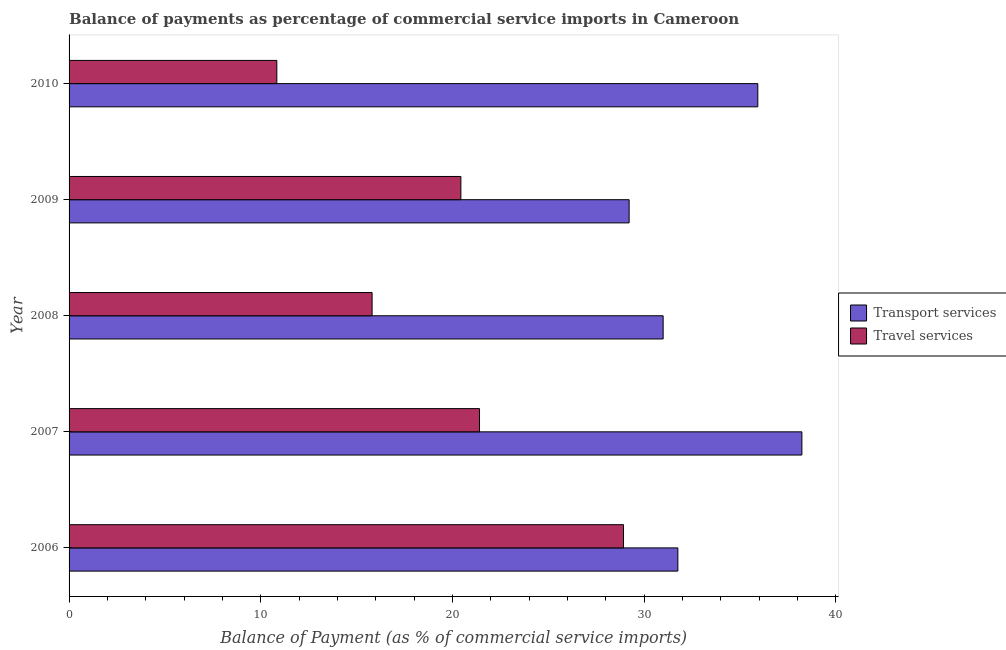How many different coloured bars are there?
Provide a succinct answer. 2. How many groups of bars are there?
Provide a short and direct response. 5. Are the number of bars per tick equal to the number of legend labels?
Make the answer very short. Yes. How many bars are there on the 2nd tick from the top?
Your response must be concise. 2. What is the label of the 5th group of bars from the top?
Provide a succinct answer. 2006. In how many cases, is the number of bars for a given year not equal to the number of legend labels?
Offer a terse response. 0. What is the balance of payments of transport services in 2009?
Make the answer very short. 29.21. Across all years, what is the maximum balance of payments of transport services?
Provide a short and direct response. 38.22. Across all years, what is the minimum balance of payments of transport services?
Give a very brief answer. 29.21. In which year was the balance of payments of travel services maximum?
Make the answer very short. 2006. In which year was the balance of payments of travel services minimum?
Your response must be concise. 2010. What is the total balance of payments of travel services in the graph?
Make the answer very short. 97.41. What is the difference between the balance of payments of travel services in 2008 and that in 2010?
Your response must be concise. 4.97. What is the difference between the balance of payments of transport services in 2009 and the balance of payments of travel services in 2006?
Keep it short and to the point. 0.29. What is the average balance of payments of transport services per year?
Provide a succinct answer. 33.22. In the year 2007, what is the difference between the balance of payments of transport services and balance of payments of travel services?
Offer a very short reply. 16.82. In how many years, is the balance of payments of travel services greater than 8 %?
Offer a terse response. 5. What is the ratio of the balance of payments of transport services in 2006 to that in 2010?
Your answer should be very brief. 0.88. Is the balance of payments of transport services in 2006 less than that in 2007?
Provide a succinct answer. Yes. What is the difference between the highest and the second highest balance of payments of travel services?
Provide a succinct answer. 7.51. What is the difference between the highest and the lowest balance of payments of travel services?
Your answer should be very brief. 18.08. In how many years, is the balance of payments of travel services greater than the average balance of payments of travel services taken over all years?
Provide a short and direct response. 3. Is the sum of the balance of payments of travel services in 2008 and 2010 greater than the maximum balance of payments of transport services across all years?
Your answer should be very brief. No. What does the 2nd bar from the top in 2006 represents?
Provide a short and direct response. Transport services. What does the 2nd bar from the bottom in 2006 represents?
Keep it short and to the point. Travel services. How many bars are there?
Provide a short and direct response. 10. Are all the bars in the graph horizontal?
Keep it short and to the point. Yes. How many years are there in the graph?
Provide a short and direct response. 5. Are the values on the major ticks of X-axis written in scientific E-notation?
Provide a succinct answer. No. What is the title of the graph?
Your answer should be compact. Balance of payments as percentage of commercial service imports in Cameroon. Does "By country of asylum" appear as one of the legend labels in the graph?
Your answer should be compact. No. What is the label or title of the X-axis?
Keep it short and to the point. Balance of Payment (as % of commercial service imports). What is the label or title of the Y-axis?
Your response must be concise. Year. What is the Balance of Payment (as % of commercial service imports) of Transport services in 2006?
Offer a terse response. 31.75. What is the Balance of Payment (as % of commercial service imports) in Travel services in 2006?
Provide a short and direct response. 28.92. What is the Balance of Payment (as % of commercial service imports) in Transport services in 2007?
Your response must be concise. 38.22. What is the Balance of Payment (as % of commercial service imports) in Travel services in 2007?
Provide a succinct answer. 21.41. What is the Balance of Payment (as % of commercial service imports) in Transport services in 2008?
Your answer should be very brief. 30.99. What is the Balance of Payment (as % of commercial service imports) in Travel services in 2008?
Ensure brevity in your answer.  15.81. What is the Balance of Payment (as % of commercial service imports) of Transport services in 2009?
Your answer should be compact. 29.21. What is the Balance of Payment (as % of commercial service imports) of Travel services in 2009?
Provide a succinct answer. 20.44. What is the Balance of Payment (as % of commercial service imports) of Transport services in 2010?
Your answer should be compact. 35.92. What is the Balance of Payment (as % of commercial service imports) in Travel services in 2010?
Keep it short and to the point. 10.84. Across all years, what is the maximum Balance of Payment (as % of commercial service imports) in Transport services?
Your response must be concise. 38.22. Across all years, what is the maximum Balance of Payment (as % of commercial service imports) in Travel services?
Your response must be concise. 28.92. Across all years, what is the minimum Balance of Payment (as % of commercial service imports) of Transport services?
Provide a short and direct response. 29.21. Across all years, what is the minimum Balance of Payment (as % of commercial service imports) in Travel services?
Offer a very short reply. 10.84. What is the total Balance of Payment (as % of commercial service imports) in Transport services in the graph?
Provide a short and direct response. 166.1. What is the total Balance of Payment (as % of commercial service imports) in Travel services in the graph?
Your answer should be very brief. 97.41. What is the difference between the Balance of Payment (as % of commercial service imports) of Transport services in 2006 and that in 2007?
Provide a succinct answer. -6.47. What is the difference between the Balance of Payment (as % of commercial service imports) of Travel services in 2006 and that in 2007?
Offer a terse response. 7.51. What is the difference between the Balance of Payment (as % of commercial service imports) of Transport services in 2006 and that in 2008?
Offer a terse response. 0.77. What is the difference between the Balance of Payment (as % of commercial service imports) of Travel services in 2006 and that in 2008?
Make the answer very short. 13.11. What is the difference between the Balance of Payment (as % of commercial service imports) in Transport services in 2006 and that in 2009?
Keep it short and to the point. 2.54. What is the difference between the Balance of Payment (as % of commercial service imports) in Travel services in 2006 and that in 2009?
Your answer should be very brief. 8.48. What is the difference between the Balance of Payment (as % of commercial service imports) of Transport services in 2006 and that in 2010?
Your response must be concise. -4.17. What is the difference between the Balance of Payment (as % of commercial service imports) in Travel services in 2006 and that in 2010?
Offer a very short reply. 18.08. What is the difference between the Balance of Payment (as % of commercial service imports) of Transport services in 2007 and that in 2008?
Provide a succinct answer. 7.24. What is the difference between the Balance of Payment (as % of commercial service imports) in Travel services in 2007 and that in 2008?
Your response must be concise. 5.6. What is the difference between the Balance of Payment (as % of commercial service imports) of Transport services in 2007 and that in 2009?
Offer a terse response. 9.01. What is the difference between the Balance of Payment (as % of commercial service imports) in Travel services in 2007 and that in 2009?
Provide a short and direct response. 0.97. What is the difference between the Balance of Payment (as % of commercial service imports) in Transport services in 2007 and that in 2010?
Offer a very short reply. 2.3. What is the difference between the Balance of Payment (as % of commercial service imports) in Travel services in 2007 and that in 2010?
Give a very brief answer. 10.57. What is the difference between the Balance of Payment (as % of commercial service imports) in Transport services in 2008 and that in 2009?
Your response must be concise. 1.77. What is the difference between the Balance of Payment (as % of commercial service imports) of Travel services in 2008 and that in 2009?
Ensure brevity in your answer.  -4.63. What is the difference between the Balance of Payment (as % of commercial service imports) of Transport services in 2008 and that in 2010?
Keep it short and to the point. -4.94. What is the difference between the Balance of Payment (as % of commercial service imports) in Travel services in 2008 and that in 2010?
Your answer should be compact. 4.97. What is the difference between the Balance of Payment (as % of commercial service imports) of Transport services in 2009 and that in 2010?
Your response must be concise. -6.71. What is the difference between the Balance of Payment (as % of commercial service imports) in Travel services in 2009 and that in 2010?
Your answer should be very brief. 9.6. What is the difference between the Balance of Payment (as % of commercial service imports) in Transport services in 2006 and the Balance of Payment (as % of commercial service imports) in Travel services in 2007?
Your answer should be very brief. 10.35. What is the difference between the Balance of Payment (as % of commercial service imports) in Transport services in 2006 and the Balance of Payment (as % of commercial service imports) in Travel services in 2008?
Your response must be concise. 15.95. What is the difference between the Balance of Payment (as % of commercial service imports) of Transport services in 2006 and the Balance of Payment (as % of commercial service imports) of Travel services in 2009?
Keep it short and to the point. 11.32. What is the difference between the Balance of Payment (as % of commercial service imports) in Transport services in 2006 and the Balance of Payment (as % of commercial service imports) in Travel services in 2010?
Offer a very short reply. 20.92. What is the difference between the Balance of Payment (as % of commercial service imports) in Transport services in 2007 and the Balance of Payment (as % of commercial service imports) in Travel services in 2008?
Make the answer very short. 22.42. What is the difference between the Balance of Payment (as % of commercial service imports) in Transport services in 2007 and the Balance of Payment (as % of commercial service imports) in Travel services in 2009?
Provide a succinct answer. 17.79. What is the difference between the Balance of Payment (as % of commercial service imports) in Transport services in 2007 and the Balance of Payment (as % of commercial service imports) in Travel services in 2010?
Your answer should be very brief. 27.39. What is the difference between the Balance of Payment (as % of commercial service imports) in Transport services in 2008 and the Balance of Payment (as % of commercial service imports) in Travel services in 2009?
Provide a succinct answer. 10.55. What is the difference between the Balance of Payment (as % of commercial service imports) in Transport services in 2008 and the Balance of Payment (as % of commercial service imports) in Travel services in 2010?
Your response must be concise. 20.15. What is the difference between the Balance of Payment (as % of commercial service imports) of Transport services in 2009 and the Balance of Payment (as % of commercial service imports) of Travel services in 2010?
Ensure brevity in your answer.  18.38. What is the average Balance of Payment (as % of commercial service imports) in Transport services per year?
Your answer should be compact. 33.22. What is the average Balance of Payment (as % of commercial service imports) of Travel services per year?
Offer a terse response. 19.48. In the year 2006, what is the difference between the Balance of Payment (as % of commercial service imports) in Transport services and Balance of Payment (as % of commercial service imports) in Travel services?
Offer a very short reply. 2.84. In the year 2007, what is the difference between the Balance of Payment (as % of commercial service imports) of Transport services and Balance of Payment (as % of commercial service imports) of Travel services?
Give a very brief answer. 16.82. In the year 2008, what is the difference between the Balance of Payment (as % of commercial service imports) of Transport services and Balance of Payment (as % of commercial service imports) of Travel services?
Provide a short and direct response. 15.18. In the year 2009, what is the difference between the Balance of Payment (as % of commercial service imports) of Transport services and Balance of Payment (as % of commercial service imports) of Travel services?
Your answer should be compact. 8.78. In the year 2010, what is the difference between the Balance of Payment (as % of commercial service imports) in Transport services and Balance of Payment (as % of commercial service imports) in Travel services?
Your answer should be very brief. 25.09. What is the ratio of the Balance of Payment (as % of commercial service imports) of Transport services in 2006 to that in 2007?
Keep it short and to the point. 0.83. What is the ratio of the Balance of Payment (as % of commercial service imports) in Travel services in 2006 to that in 2007?
Offer a very short reply. 1.35. What is the ratio of the Balance of Payment (as % of commercial service imports) in Transport services in 2006 to that in 2008?
Provide a short and direct response. 1.02. What is the ratio of the Balance of Payment (as % of commercial service imports) in Travel services in 2006 to that in 2008?
Ensure brevity in your answer.  1.83. What is the ratio of the Balance of Payment (as % of commercial service imports) in Transport services in 2006 to that in 2009?
Make the answer very short. 1.09. What is the ratio of the Balance of Payment (as % of commercial service imports) in Travel services in 2006 to that in 2009?
Ensure brevity in your answer.  1.42. What is the ratio of the Balance of Payment (as % of commercial service imports) in Transport services in 2006 to that in 2010?
Offer a very short reply. 0.88. What is the ratio of the Balance of Payment (as % of commercial service imports) of Travel services in 2006 to that in 2010?
Give a very brief answer. 2.67. What is the ratio of the Balance of Payment (as % of commercial service imports) in Transport services in 2007 to that in 2008?
Your answer should be compact. 1.23. What is the ratio of the Balance of Payment (as % of commercial service imports) of Travel services in 2007 to that in 2008?
Offer a very short reply. 1.35. What is the ratio of the Balance of Payment (as % of commercial service imports) in Transport services in 2007 to that in 2009?
Offer a terse response. 1.31. What is the ratio of the Balance of Payment (as % of commercial service imports) in Travel services in 2007 to that in 2009?
Ensure brevity in your answer.  1.05. What is the ratio of the Balance of Payment (as % of commercial service imports) of Transport services in 2007 to that in 2010?
Give a very brief answer. 1.06. What is the ratio of the Balance of Payment (as % of commercial service imports) of Travel services in 2007 to that in 2010?
Offer a terse response. 1.98. What is the ratio of the Balance of Payment (as % of commercial service imports) of Transport services in 2008 to that in 2009?
Your answer should be very brief. 1.06. What is the ratio of the Balance of Payment (as % of commercial service imports) of Travel services in 2008 to that in 2009?
Provide a short and direct response. 0.77. What is the ratio of the Balance of Payment (as % of commercial service imports) of Transport services in 2008 to that in 2010?
Keep it short and to the point. 0.86. What is the ratio of the Balance of Payment (as % of commercial service imports) in Travel services in 2008 to that in 2010?
Ensure brevity in your answer.  1.46. What is the ratio of the Balance of Payment (as % of commercial service imports) of Transport services in 2009 to that in 2010?
Provide a short and direct response. 0.81. What is the ratio of the Balance of Payment (as % of commercial service imports) of Travel services in 2009 to that in 2010?
Your answer should be compact. 1.89. What is the difference between the highest and the second highest Balance of Payment (as % of commercial service imports) in Transport services?
Offer a terse response. 2.3. What is the difference between the highest and the second highest Balance of Payment (as % of commercial service imports) of Travel services?
Your answer should be very brief. 7.51. What is the difference between the highest and the lowest Balance of Payment (as % of commercial service imports) in Transport services?
Offer a terse response. 9.01. What is the difference between the highest and the lowest Balance of Payment (as % of commercial service imports) in Travel services?
Offer a terse response. 18.08. 